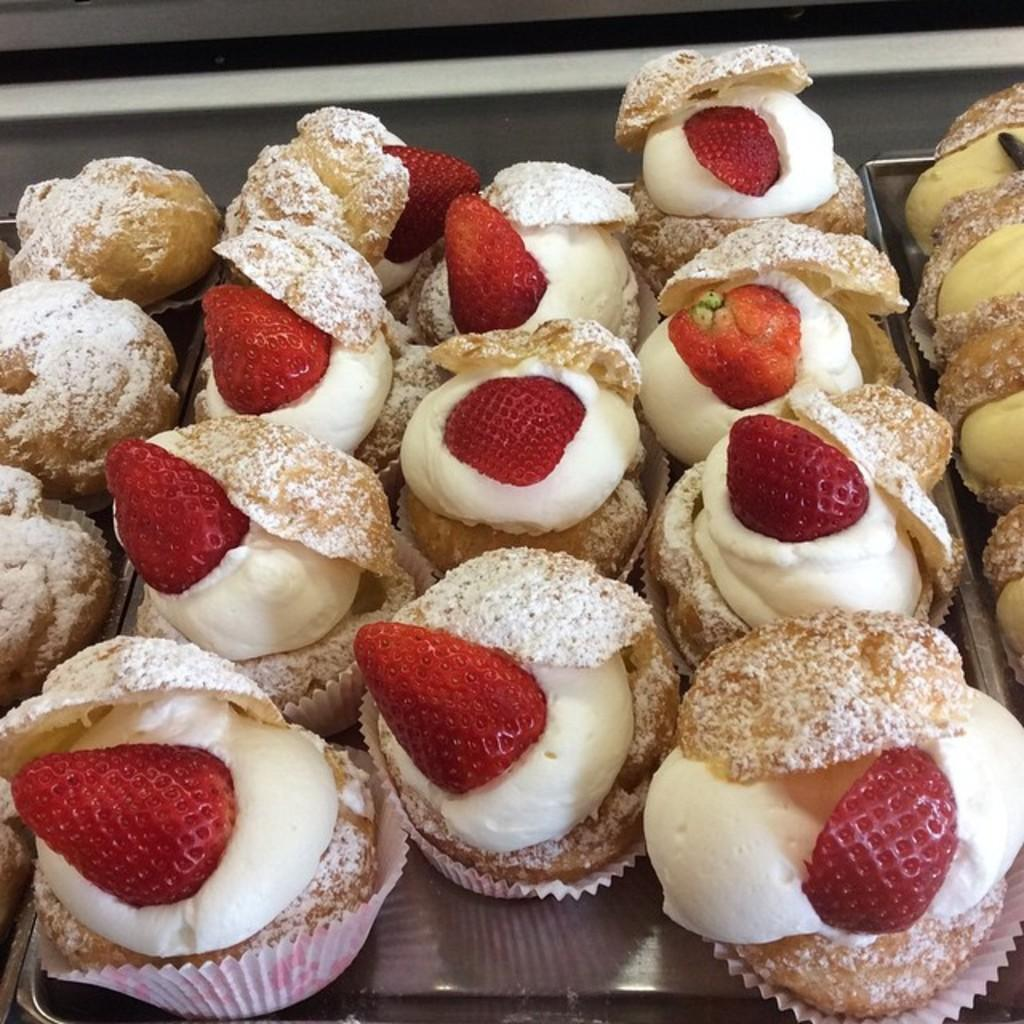What is on the plate that is visible in the image? The plate contains strawberries. What are the strawberries placed on in the image? The strawberries are on cakes. What type of wrench is being used to cut the cakes in the image? There is no wrench present in the image, and the cakes are not being cut. 